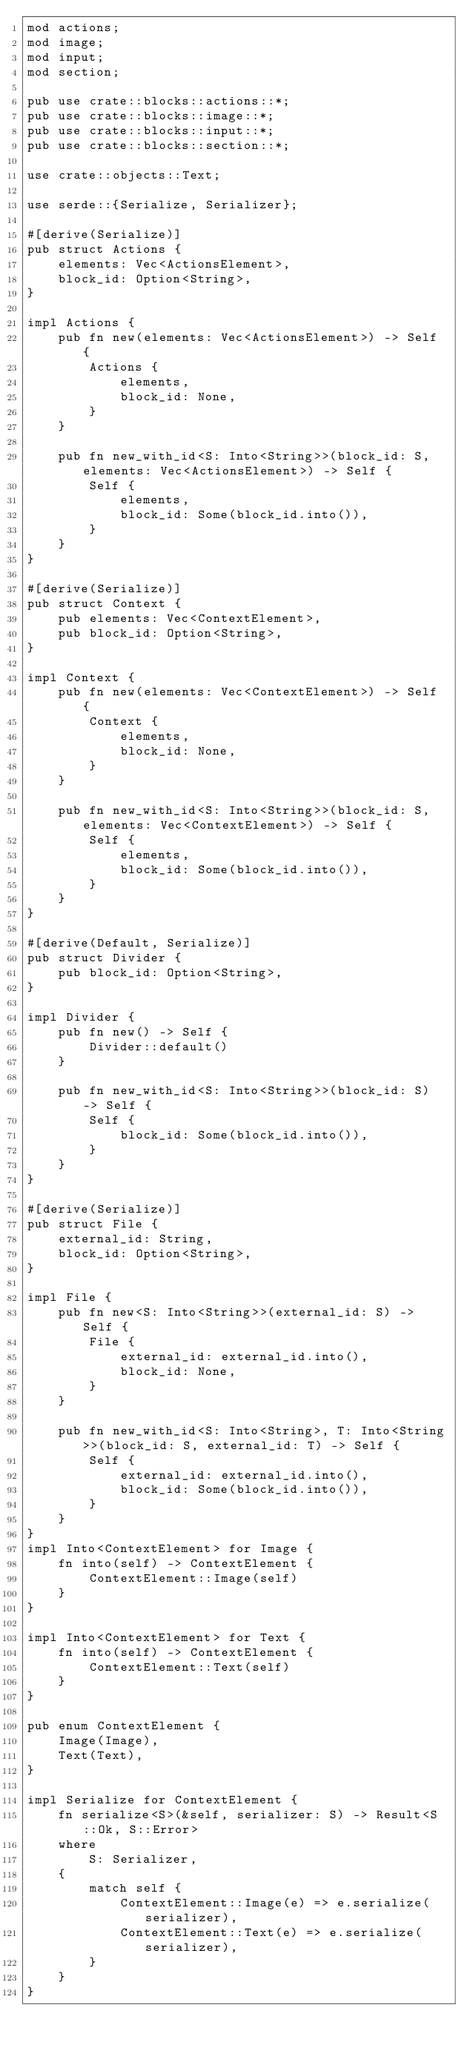<code> <loc_0><loc_0><loc_500><loc_500><_Rust_>mod actions;
mod image;
mod input;
mod section;

pub use crate::blocks::actions::*;
pub use crate::blocks::image::*;
pub use crate::blocks::input::*;
pub use crate::blocks::section::*;

use crate::objects::Text;

use serde::{Serialize, Serializer};

#[derive(Serialize)]
pub struct Actions {
    elements: Vec<ActionsElement>,
    block_id: Option<String>,
}

impl Actions {
    pub fn new(elements: Vec<ActionsElement>) -> Self {
        Actions {
            elements,
            block_id: None,
        }
    }

    pub fn new_with_id<S: Into<String>>(block_id: S, elements: Vec<ActionsElement>) -> Self {
        Self {
            elements,
            block_id: Some(block_id.into()),
        }
    }
}

#[derive(Serialize)]
pub struct Context {
    pub elements: Vec<ContextElement>,
    pub block_id: Option<String>,
}

impl Context {
    pub fn new(elements: Vec<ContextElement>) -> Self {
        Context {
            elements,
            block_id: None,
        }
    }

    pub fn new_with_id<S: Into<String>>(block_id: S, elements: Vec<ContextElement>) -> Self {
        Self {
            elements,
            block_id: Some(block_id.into()),
        }
    }
}

#[derive(Default, Serialize)]
pub struct Divider {
    pub block_id: Option<String>,
}

impl Divider {
    pub fn new() -> Self {
        Divider::default()
    }

    pub fn new_with_id<S: Into<String>>(block_id: S) -> Self {
        Self {
            block_id: Some(block_id.into()),
        }
    }
}

#[derive(Serialize)]
pub struct File {
    external_id: String,
    block_id: Option<String>,
}

impl File {
    pub fn new<S: Into<String>>(external_id: S) -> Self {
        File {
            external_id: external_id.into(),
            block_id: None,
        }
    }

    pub fn new_with_id<S: Into<String>, T: Into<String>>(block_id: S, external_id: T) -> Self {
        Self {
            external_id: external_id.into(),
            block_id: Some(block_id.into()),
        }
    }
}
impl Into<ContextElement> for Image {
    fn into(self) -> ContextElement {
        ContextElement::Image(self)
    }
}

impl Into<ContextElement> for Text {
    fn into(self) -> ContextElement {
        ContextElement::Text(self)
    }
}

pub enum ContextElement {
    Image(Image),
    Text(Text),
}

impl Serialize for ContextElement {
    fn serialize<S>(&self, serializer: S) -> Result<S::Ok, S::Error>
    where
        S: Serializer,
    {
        match self {
            ContextElement::Image(e) => e.serialize(serializer),
            ContextElement::Text(e) => e.serialize(serializer),
        }
    }
}

</code> 